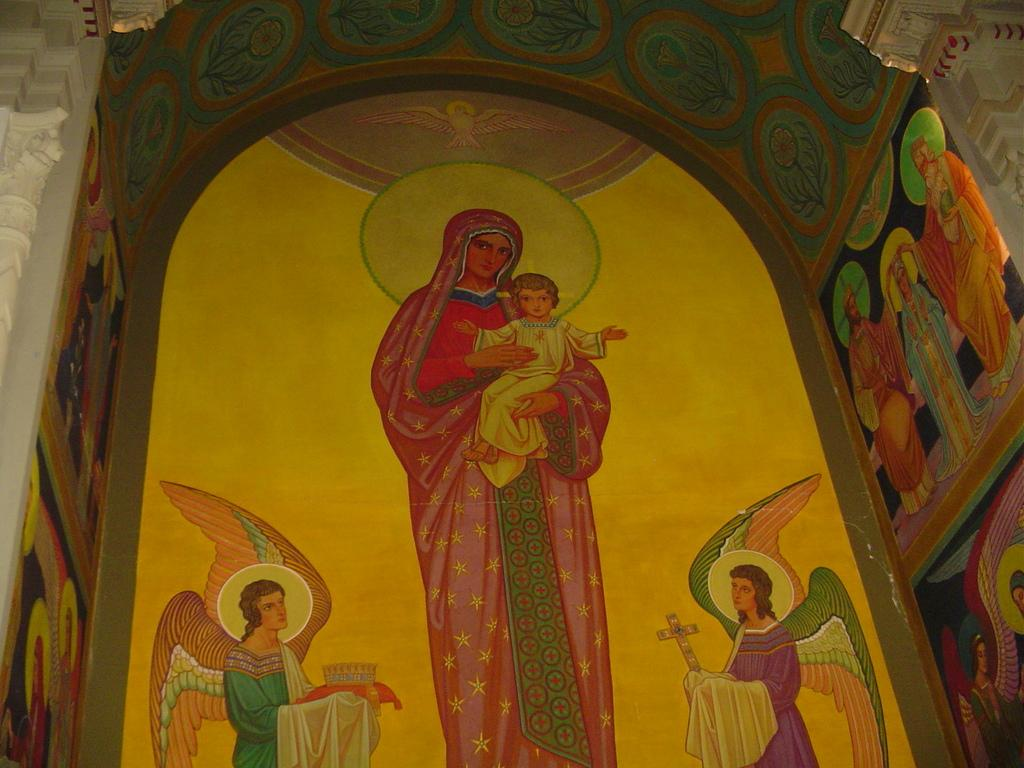What is the main subject of the image? The image contains a painting. What is depicted in the painting? The painting depicts people and a bird. What architectural elements are included in the painting? The painting includes pillars and an arch. What type of drawer is visible in the painting? There is no drawer present in the painting; it depicts people, a bird, pillars, and an arch. What color is the chalk used to draw the woman in the painting? There is no woman depicted in the painting; it features people and a bird. 